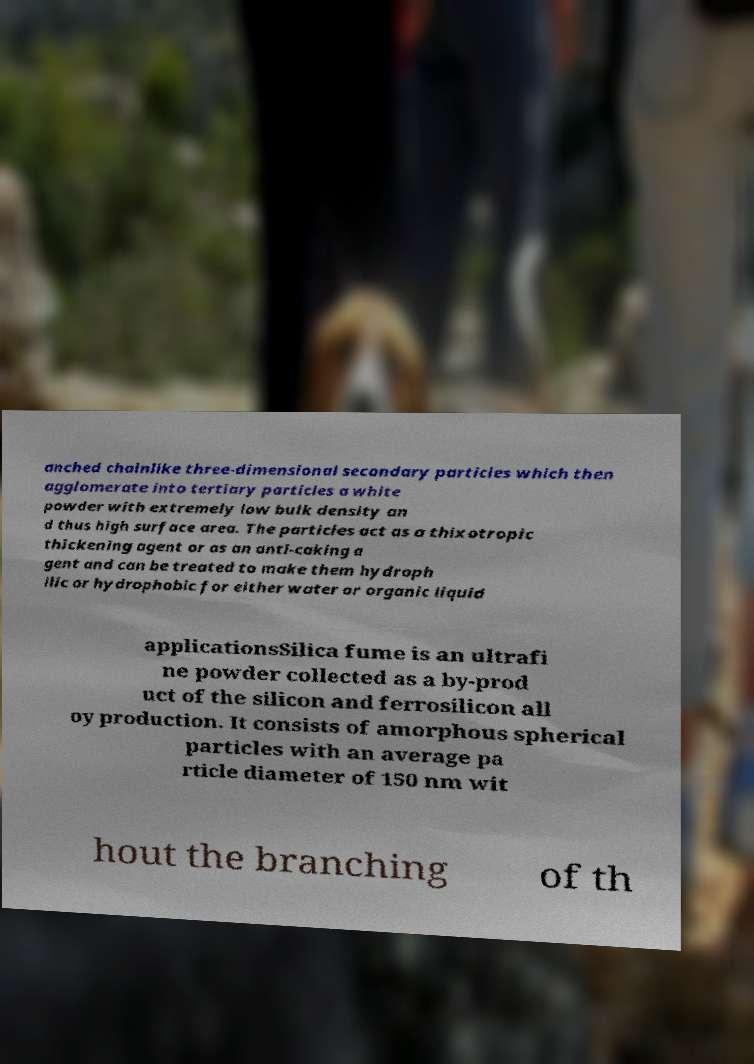Please read and relay the text visible in this image. What does it say? anched chainlike three-dimensional secondary particles which then agglomerate into tertiary particles a white powder with extremely low bulk density an d thus high surface area. The particles act as a thixotropic thickening agent or as an anti-caking a gent and can be treated to make them hydroph ilic or hydrophobic for either water or organic liquid applicationsSilica fume is an ultrafi ne powder collected as a by-prod uct of the silicon and ferrosilicon all oy production. It consists of amorphous spherical particles with an average pa rticle diameter of 150 nm wit hout the branching of th 